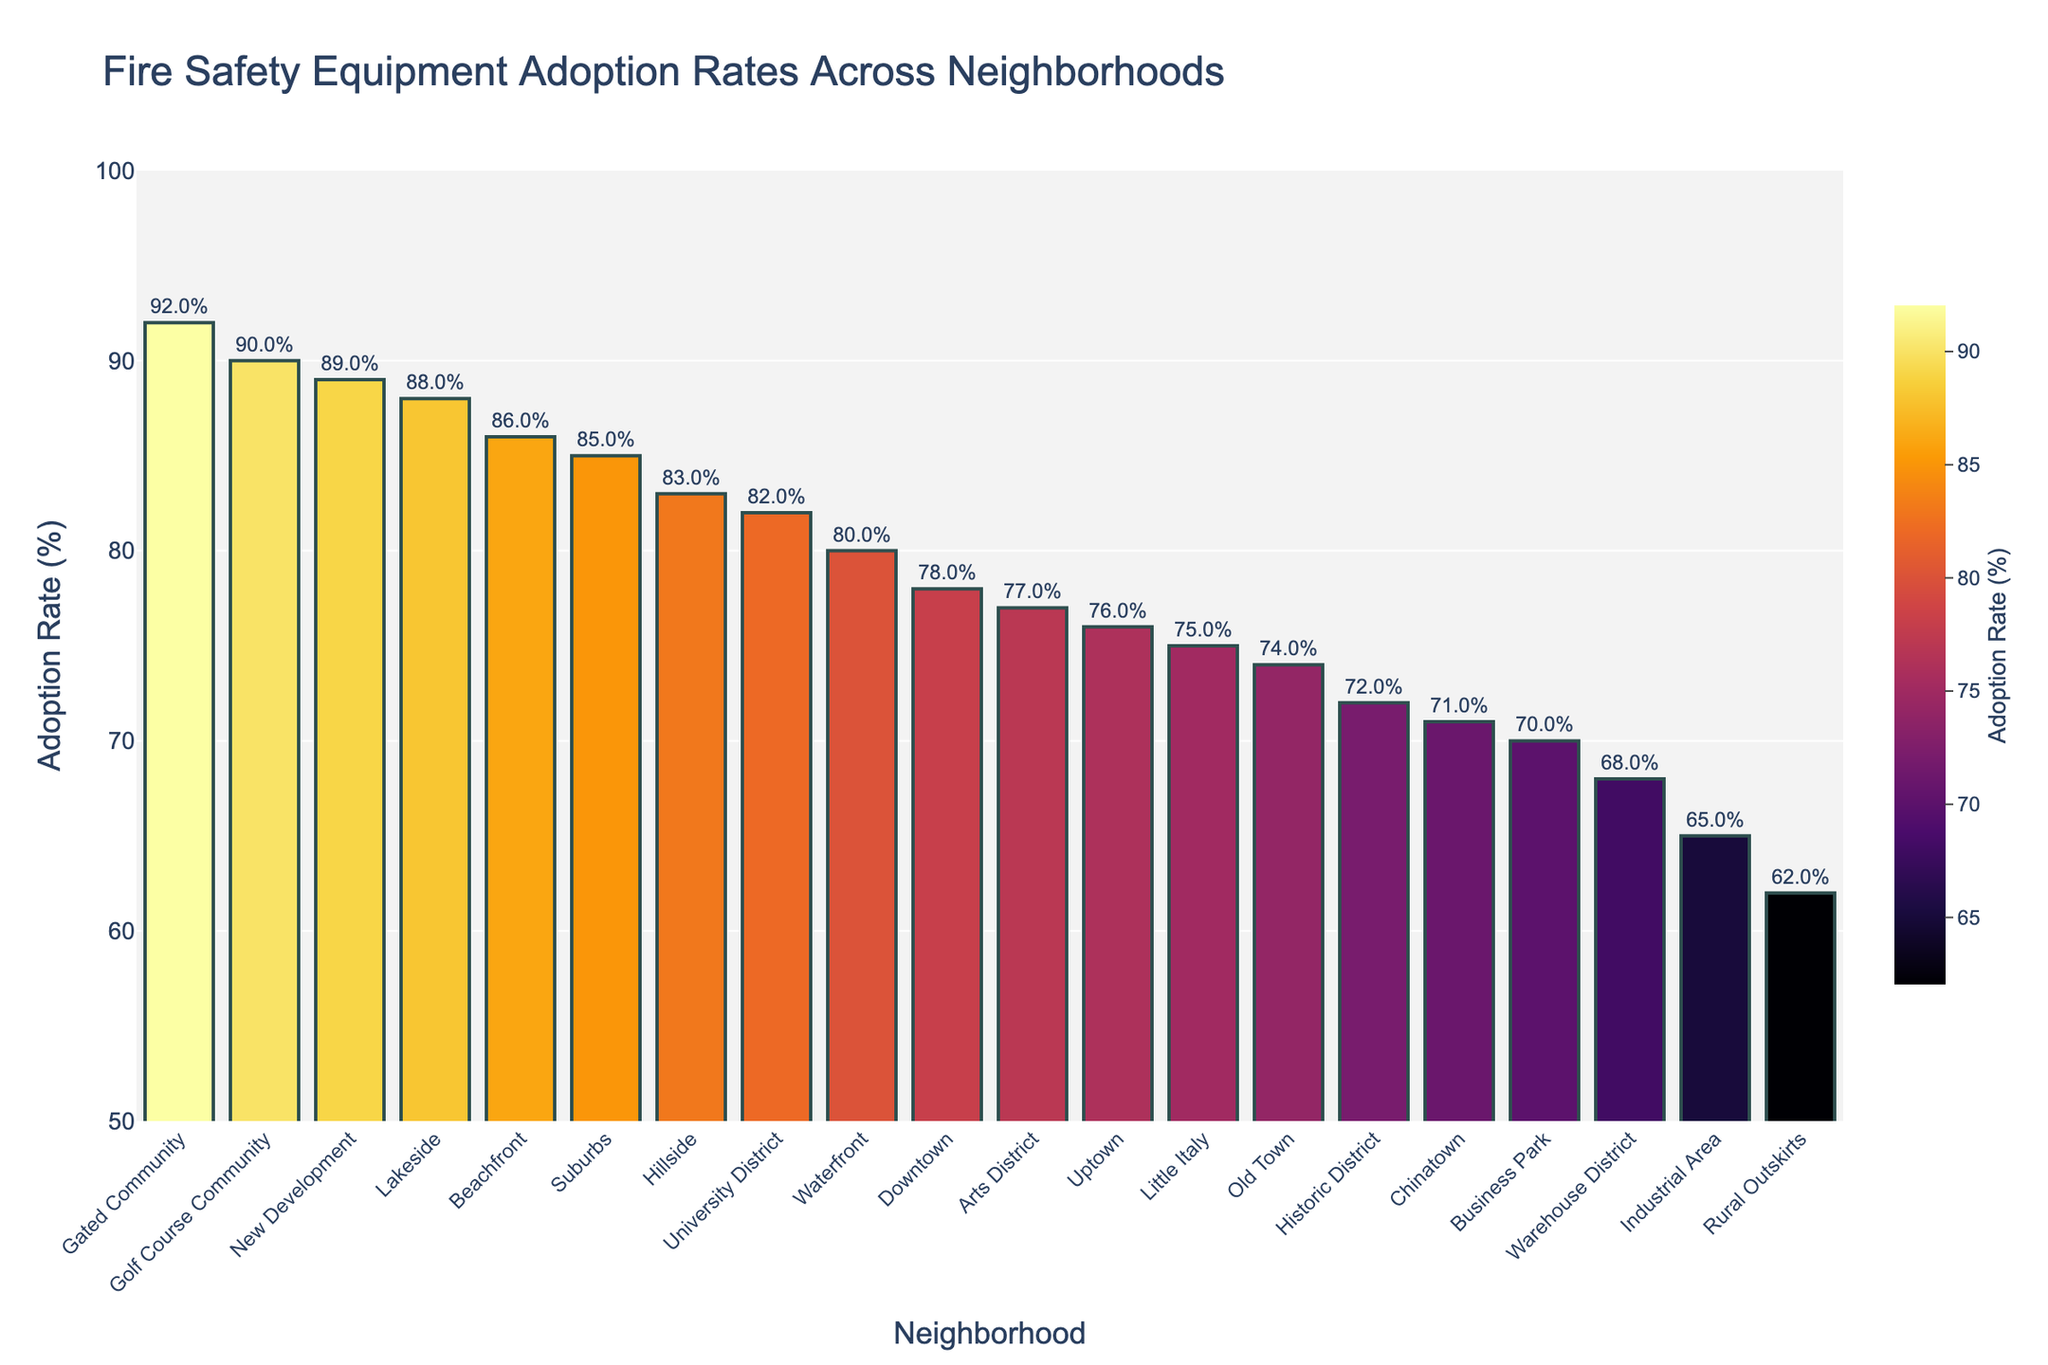Which neighborhood has the highest adoption rate? The neighborhood with the tallest bar represents the highest adoption rate. The tallest bar is for the "Gated Community," which has an adoption rate of 92%.
Answer: Gated Community What is the adoption rate for the Industrial Area? The bar corresponding to the "Industrial Area" can be examined to find its height. The text label on top of the bar shows the adoption rate, which is 65%.
Answer: 65% Which two neighborhoods have the smallest difference in adoption rates? Comparing all neighboring bars, "Chinatown" and "Little Italy" appear to have the smallest difference. "Chinatown" has an adoption rate of 71%, and "Little Italy" has 75%, so the difference is 4%.
Answer: Chinatown and Little Italy How many neighborhoods have an adoption rate of 80% or more? By counting all bars with a height representing an adoption rate of 80 or higher, the neighborhoods that meet this criterion are Suburbs, Waterfront, University District, Lakeside, New Development, Beachfront, and Golf Course Community. There are 7 such neighborhoods.
Answer: 7 What is the median adoption rate for all neighborhoods? To find the median, first list all adoption rates in ascending order: 62, 65, 68, 70, 71, 72, 74, 75, 76, 77, 78, 80, 82, 83, 85, 86, 88, 89, 90, 92. The median value is the middle one, so the 10th and 11th values are 77 and 78. The average of these two is (77 + 78)/2 = 77.5.
Answer: 77.5 Which neighborhoods have adoption rates in the range of 70% to 75%? Looking for neighborhoods where the height of the bars falls within 70 to 75%. The corresponding neighborhoods are the Business Park (70%), Chinatown (71%), Historic District (72%), and Old Town (74%).
Answer: Business Park, Chinatown, Historic District, Old Town What is the difference in adoption rates between Downtown and Gated Community? The adoption rate for Downtown is 78%, and for Gated Community it is 92%. The difference is 92% - 78% = 14%.
Answer: 14% Which neighborhood ranks second in terms of adoption rate? By identifying the second tallest bar, we can see it's the bar for "New Development" with an 89% adoption rate.
Answer: New Development If we exclude the three neighborhoods with the highest adoption rates, what is the new average adoption rate for the remaining neighborhoods? Exclude Gated Community (92%), New Development (89%), and Golf Course Community (90%). The sum of the remaining adoption rates is 78 + 85 + 72 + 80 + 65 + 82 + 76 + 88 + 70 + 62 + 74 + 77 + 83 + 71 + 75 + 86 + 68 = 1334. There are 17 neighborhoods left, so the average is 1334 / 17 ≈ 78.47%.
Answer: 78.47% 